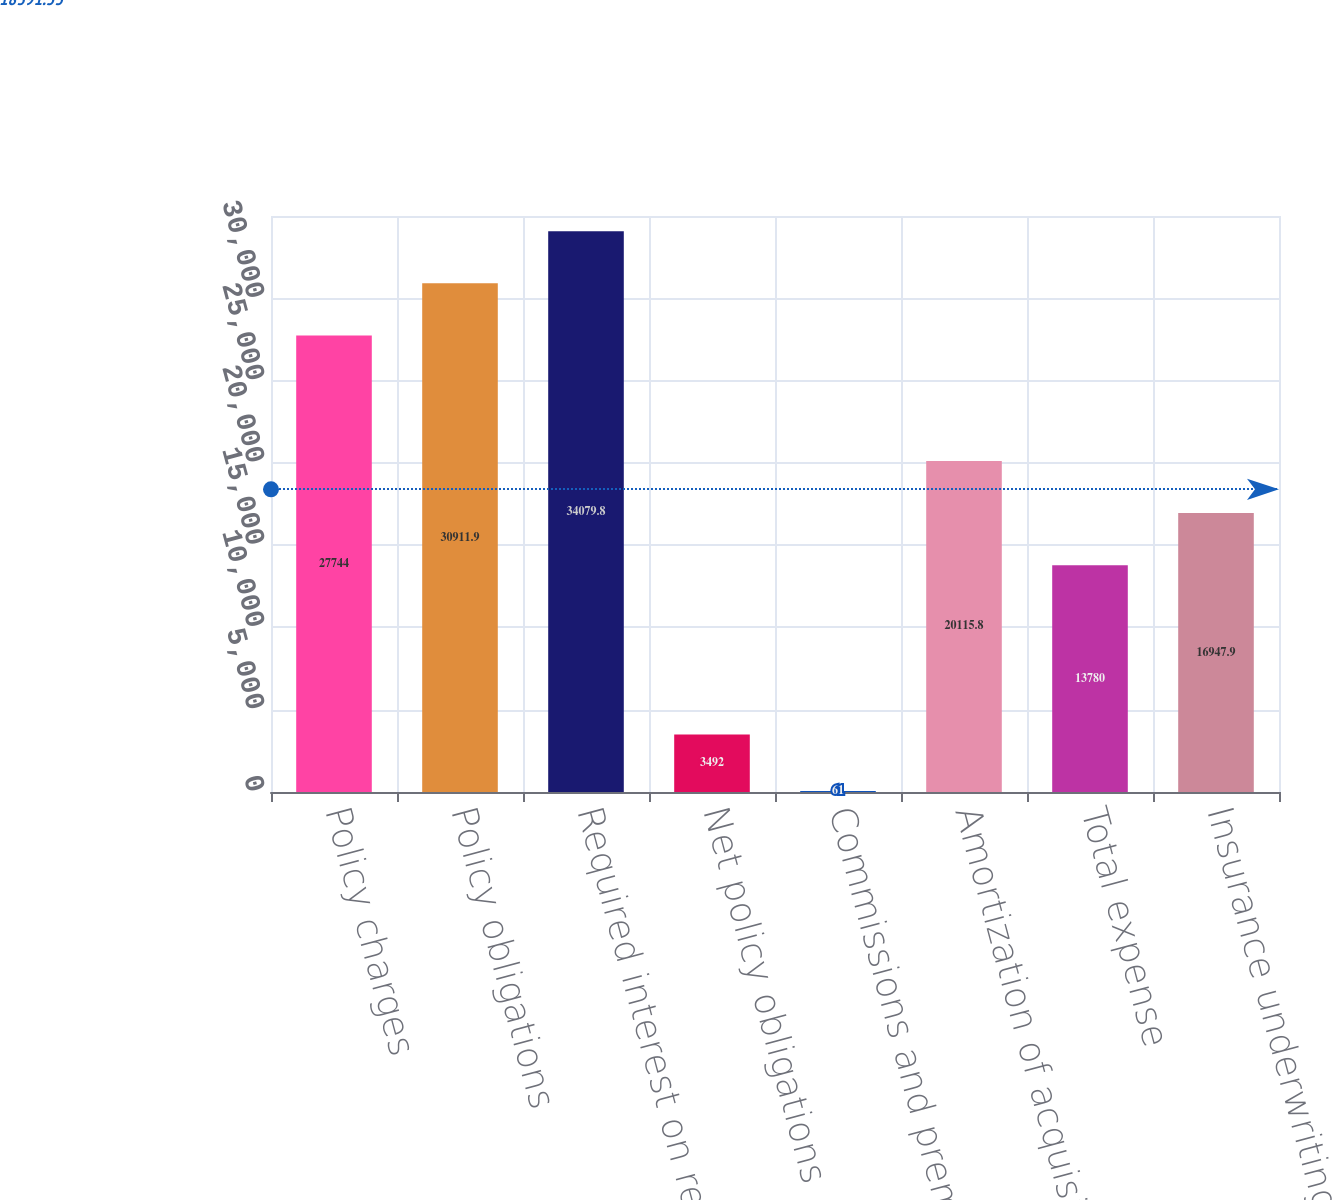Convert chart to OTSL. <chart><loc_0><loc_0><loc_500><loc_500><bar_chart><fcel>Policy charges<fcel>Policy obligations<fcel>Required interest on reserves<fcel>Net policy obligations<fcel>Commissions and premium taxes<fcel>Amortization of acquisition<fcel>Total expense<fcel>Insurance underwriting margin<nl><fcel>27744<fcel>30911.9<fcel>34079.8<fcel>3492<fcel>61<fcel>20115.8<fcel>13780<fcel>16947.9<nl></chart> 